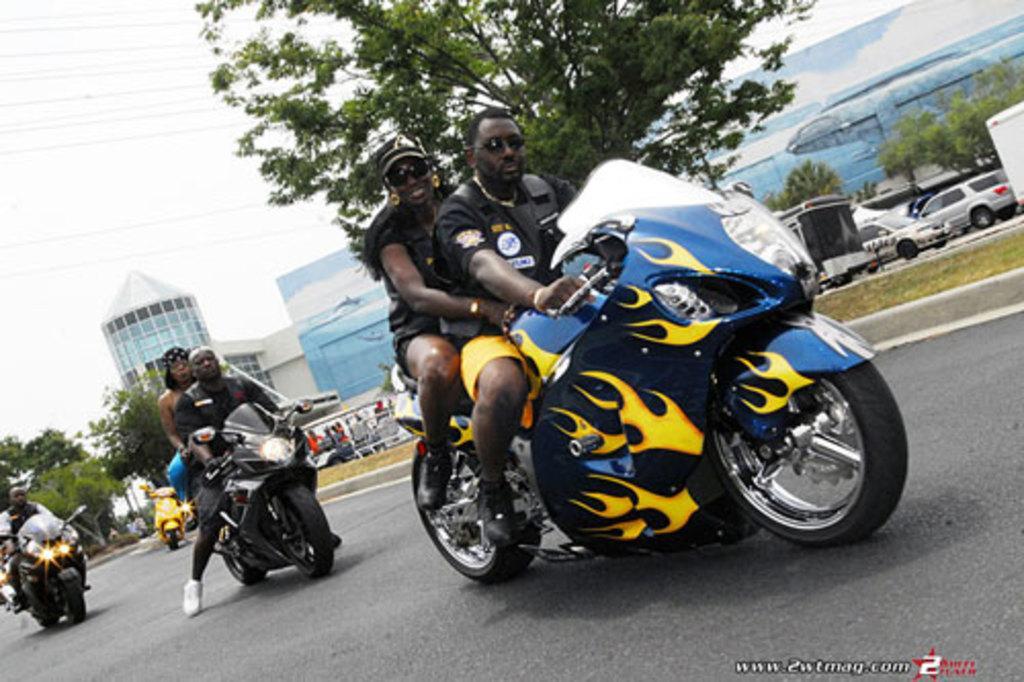In one or two sentences, can you explain what this image depicts? There is a road which is of black color and there are some bikes on which peoples are sitting and in the background there is building which is blue color and there is grass. 